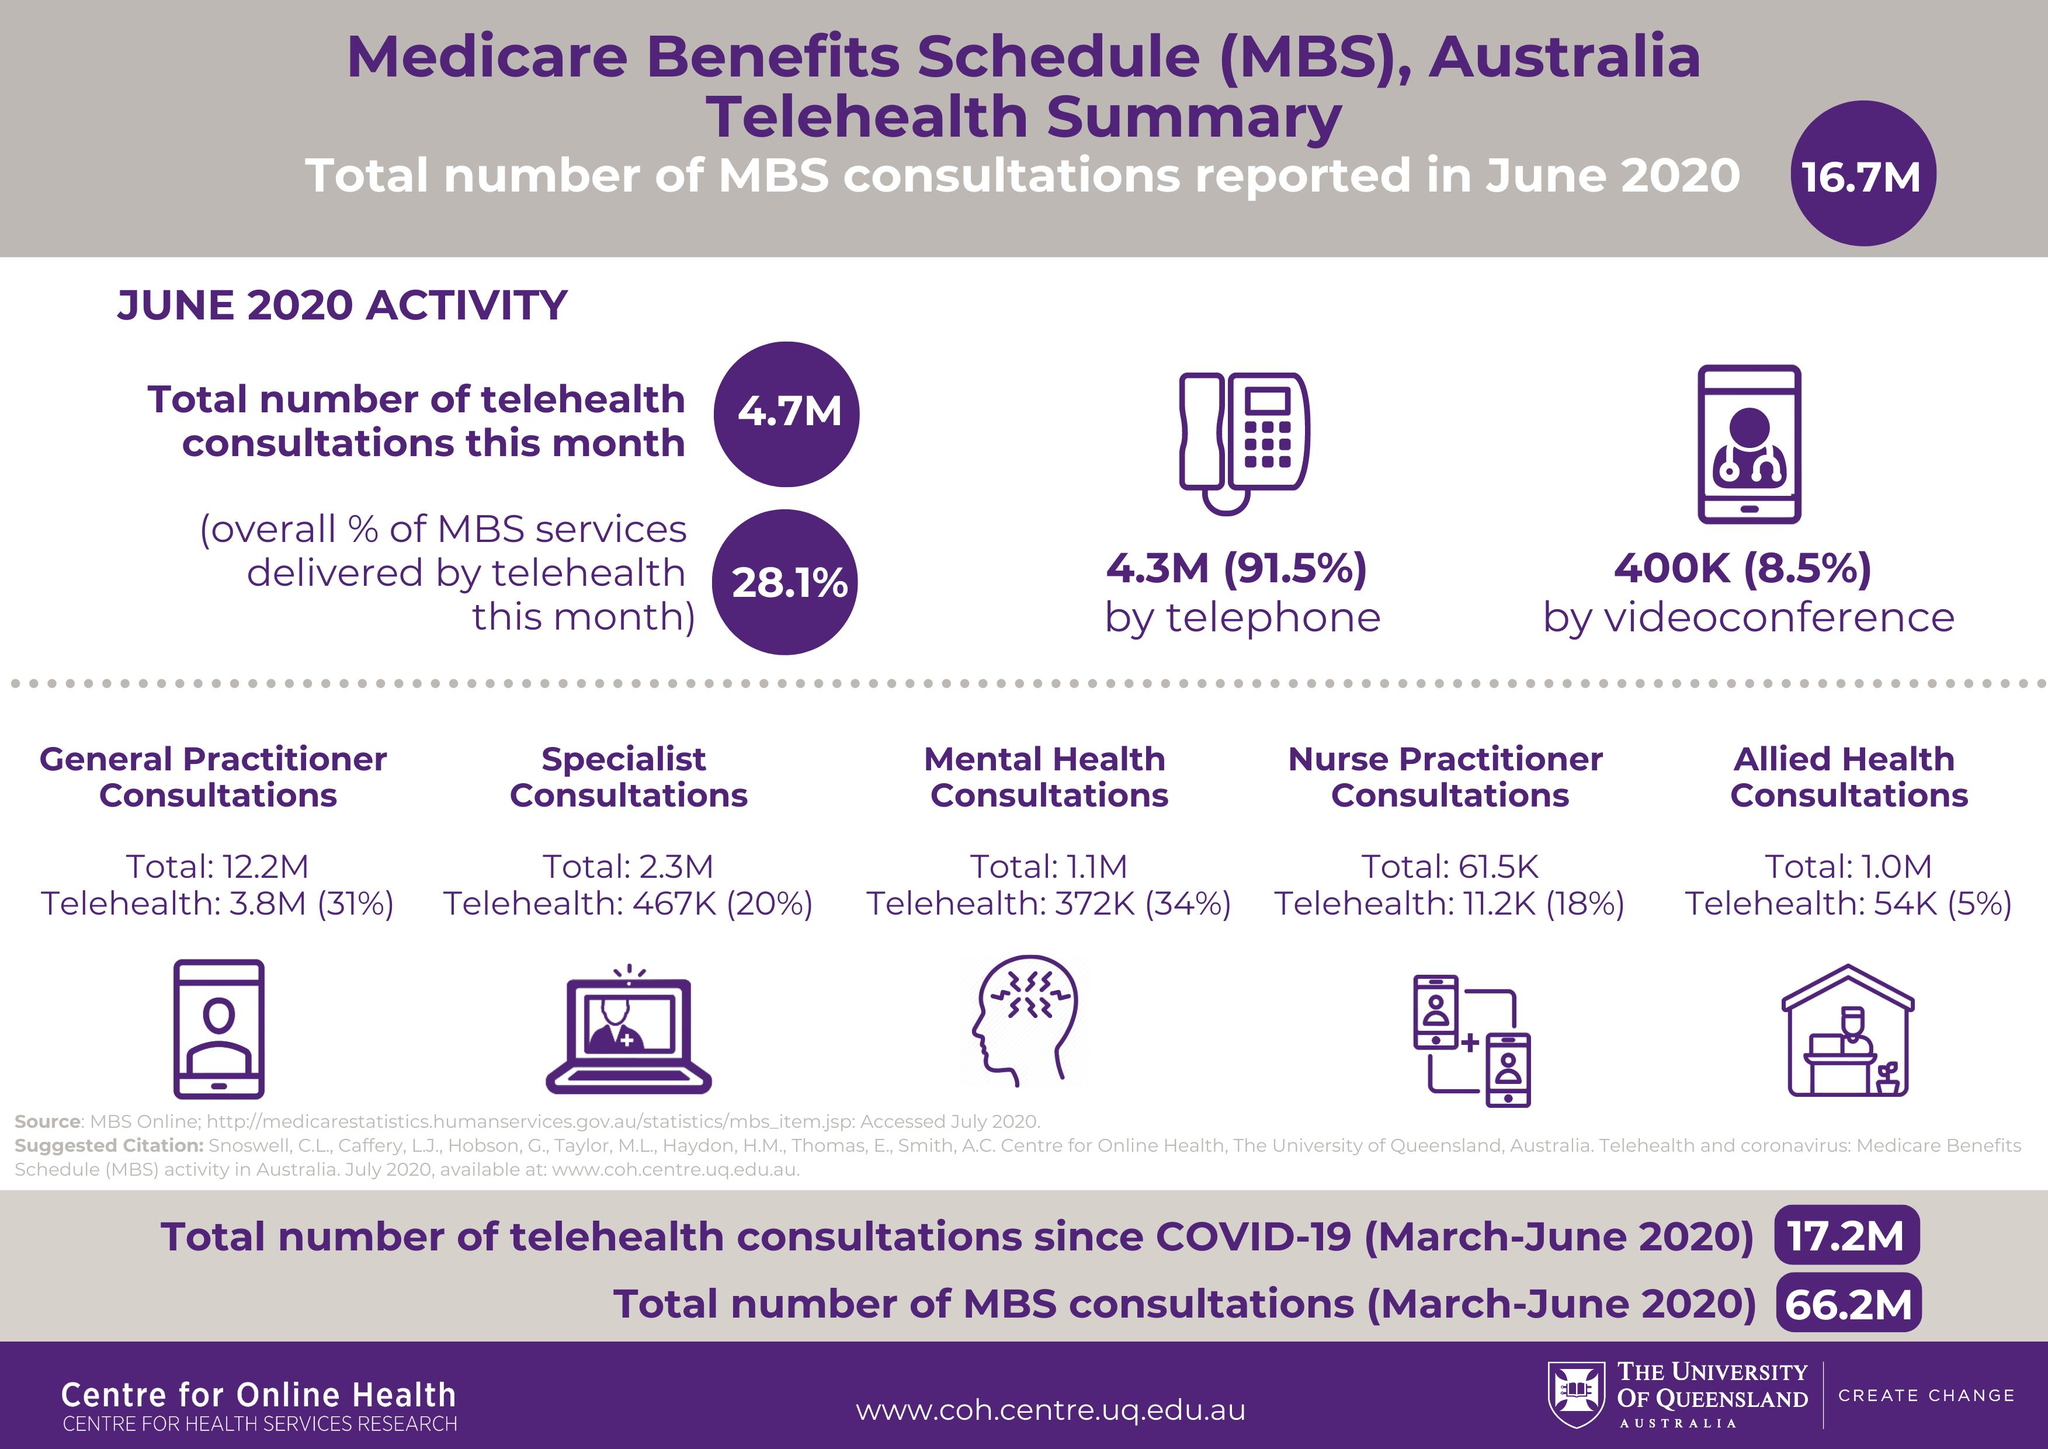Give some essential details in this illustration. The total number of telehealth consultations in millions during the period of March to May 2020 was 12.5. In June 2020, approximately 4.7 million consultations were conducted via phone or videoconference. During June 2020, a significant percentage of consultations were conducted via phone, with 91.5% of consultations being held over the phone. The total count of specialist consultations and mental health consultations is approximately 3.4 million. The total MBS consultation from March to May 2020 was approximately 49.5 million. 